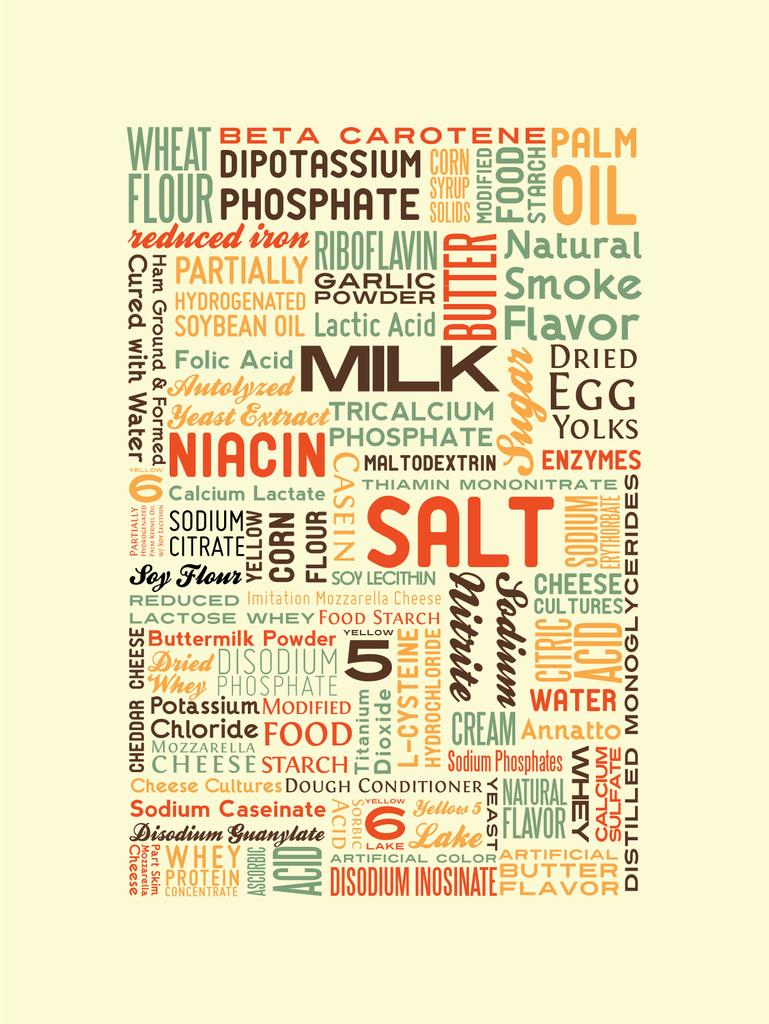Provide a one-sentence caption for the provided image. A graphic displays food related words, such as milk, salt and cream. 